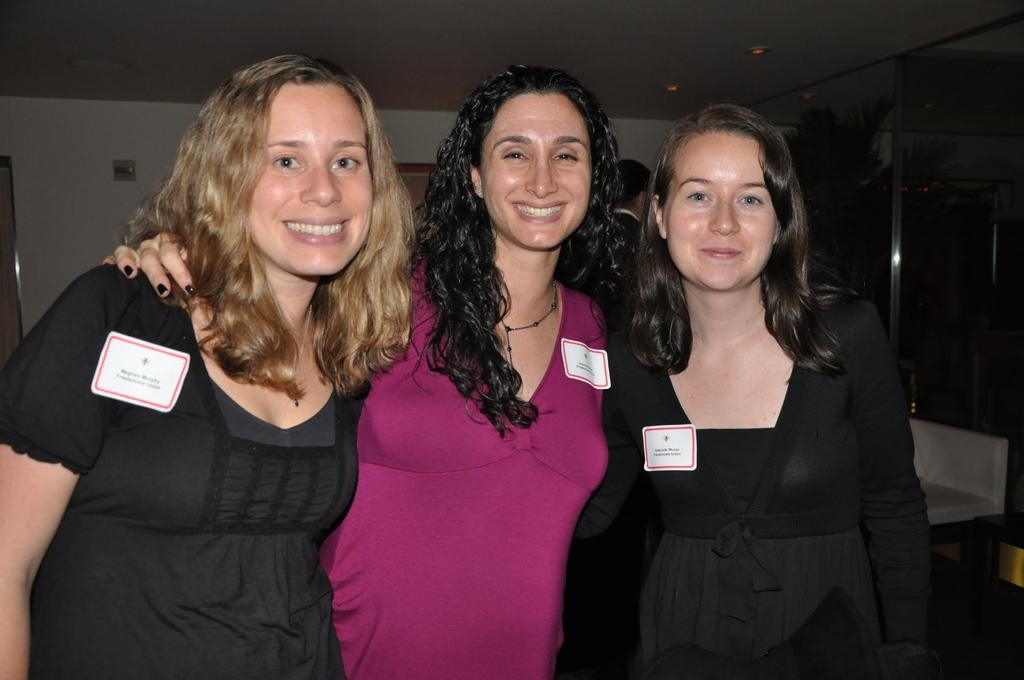How many women are in the image? There are three women in the image. What are the women doing in the image? The women are standing and smiling. What can be seen in the background of the image? There is a wall and at least one other person in the background of the image. What is located at the top of the image? There are lights at the top of the image. Can you hear the owl hooting in the image? There is no owl present in the image, so it is not possible to hear an owl hooting. What type of tiger can be seen in the image? There is no tiger present in the image. 